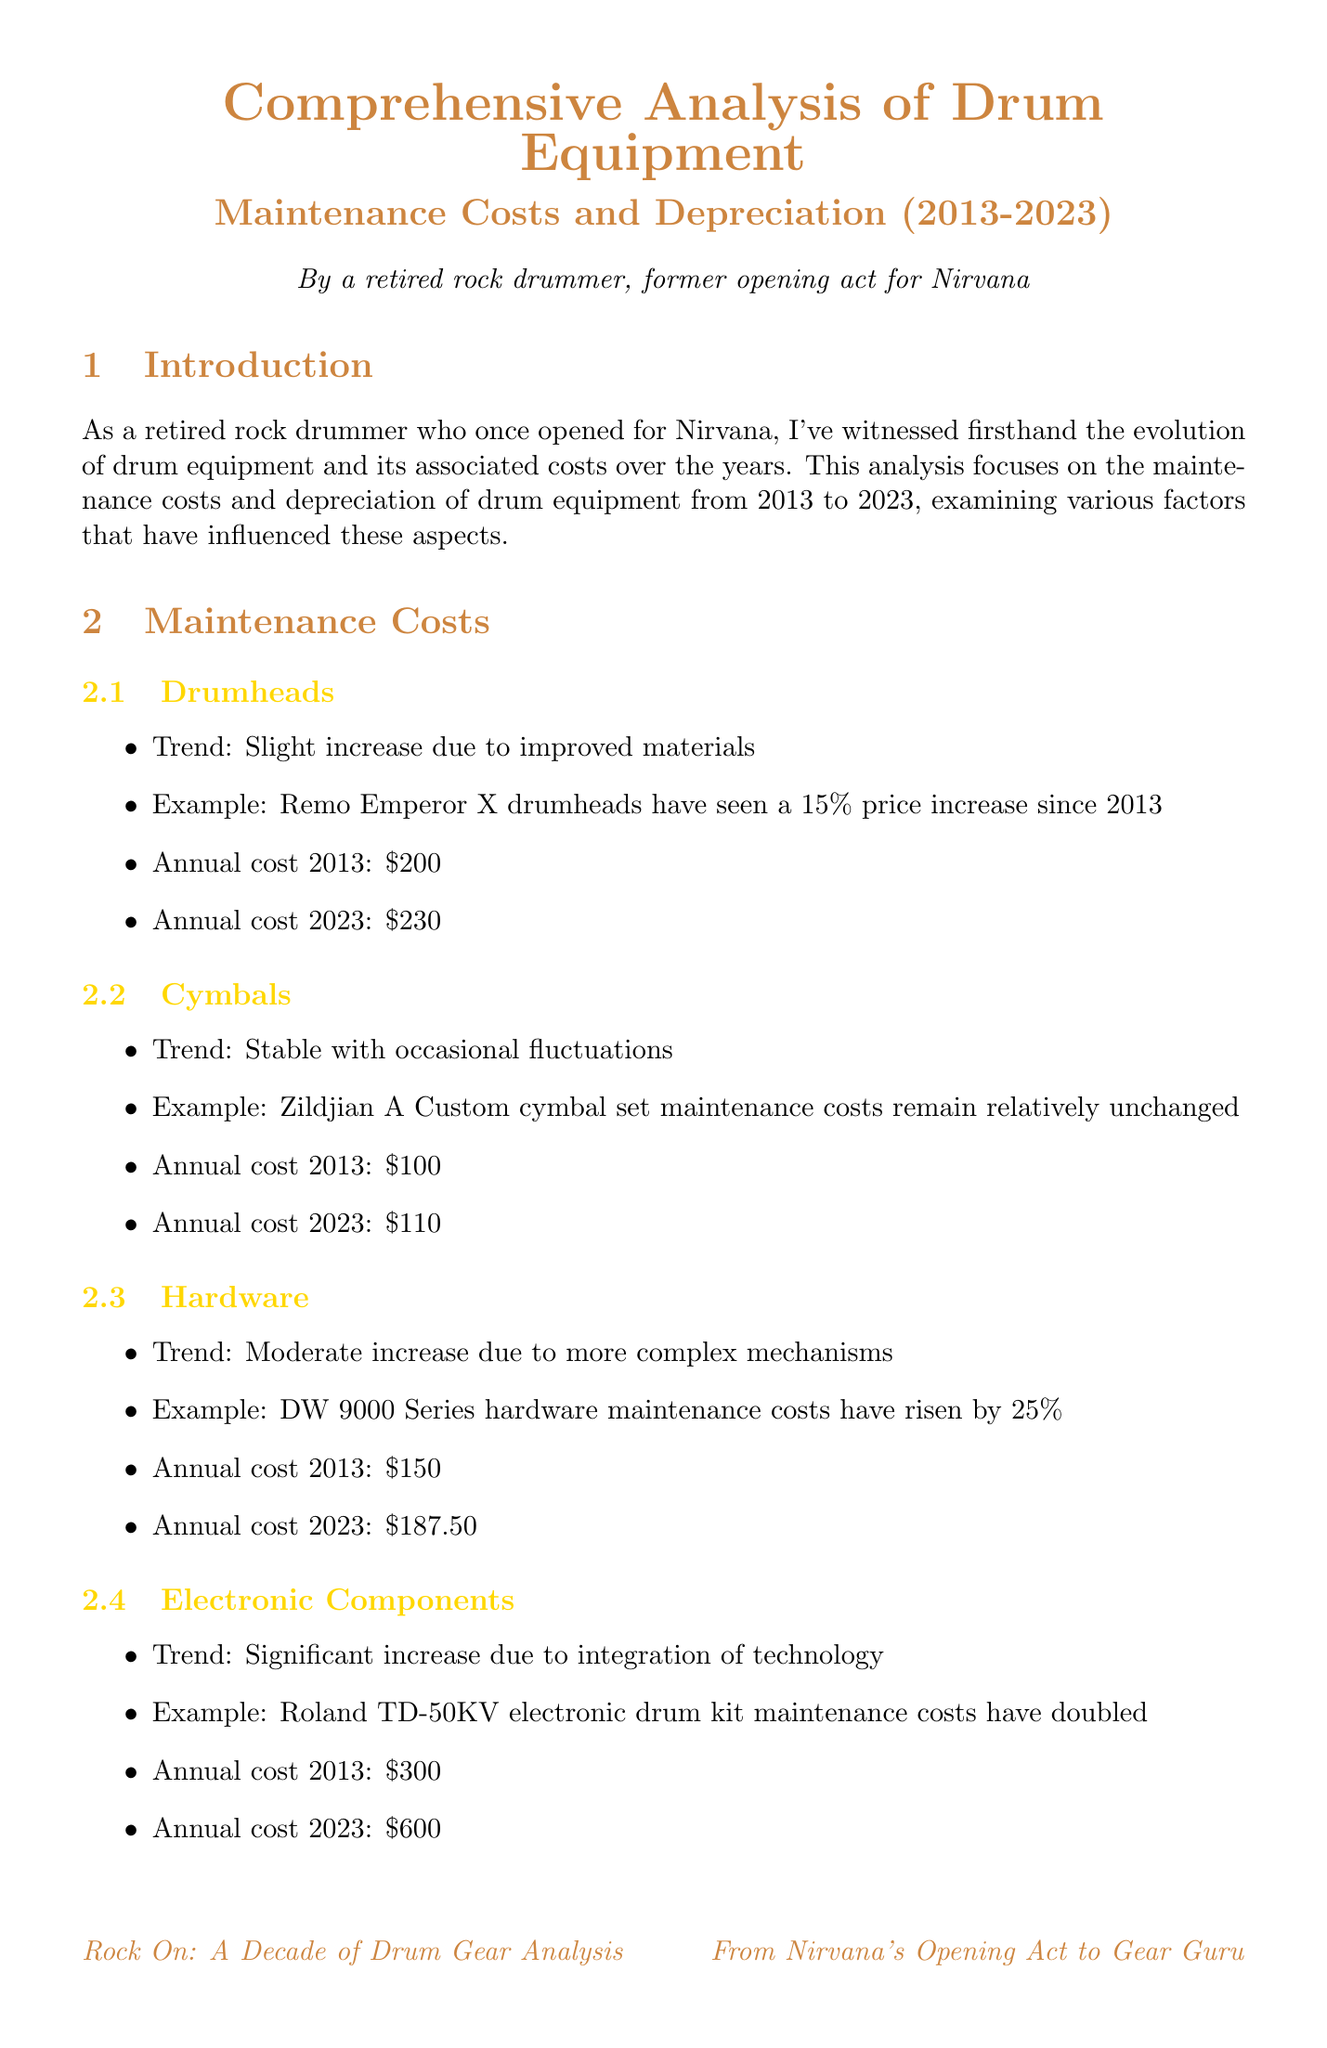what is the trend for drumheads maintenance costs? The trend indicates a slight increase due to improved materials, with specific examples showing a price rise over the decade.
Answer: slight increase due to improved materials what was the annual cost for electronic components in 2013? The document lists the annual cost for electronic components in 2013, which was specified in the maintenance costs section.
Answer: $300 what is the depreciation rate for acoustic kits? The document provides the depreciation rate for each equipment type, including acoustic kits.
Answer: 4% per year how much has the maintenance cost for the vintage Ludwig Vistalite kit increased over the decade? This information is found in the case studies section, which mentions the specific increase percentage over the ten-year period.
Answer: 25% which equipment type has seen the most significant maintenance cost increase? The document discusses trends in maintenance costs for various equipment types and highlights the one that has doubled in maintenance costs since 2013.
Answer: electronic components what percentage of value does an Alesis DM10 kit retain in 2023? The depreciation section includes specifics about the value retained by the Alesis DM10 kit from 2013 to 2023.
Answer: 30% what is one factor affecting costs and depreciation? The document lists several factors influencing maintenance costs and depreciation rates in a bulleted format.
Answer: technological advancements which snare drum has appreciated in value according to the analysis? The analysis mentions a specific example of a snare drum that has appreciated, with details available in the depreciation section.
Answer: Ludwig Black Beauty 